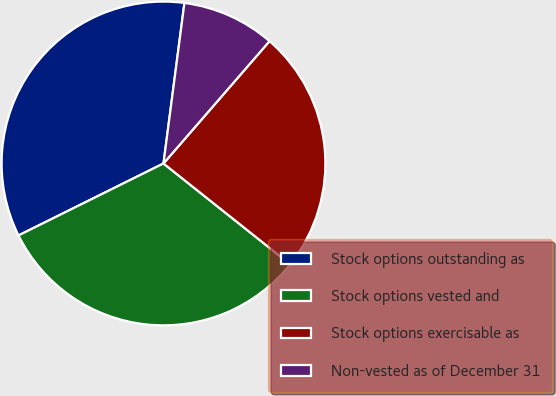Convert chart. <chart><loc_0><loc_0><loc_500><loc_500><pie_chart><fcel>Stock options outstanding as<fcel>Stock options vested and<fcel>Stock options exercisable as<fcel>Non-vested as of December 31<nl><fcel>34.4%<fcel>31.97%<fcel>24.33%<fcel>9.3%<nl></chart> 